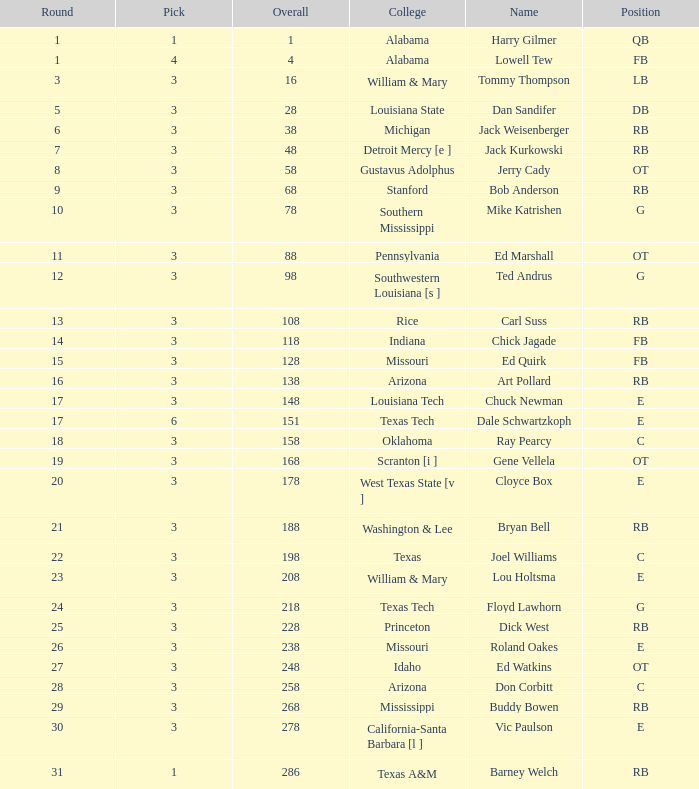What is stanford's average overall? 68.0. 